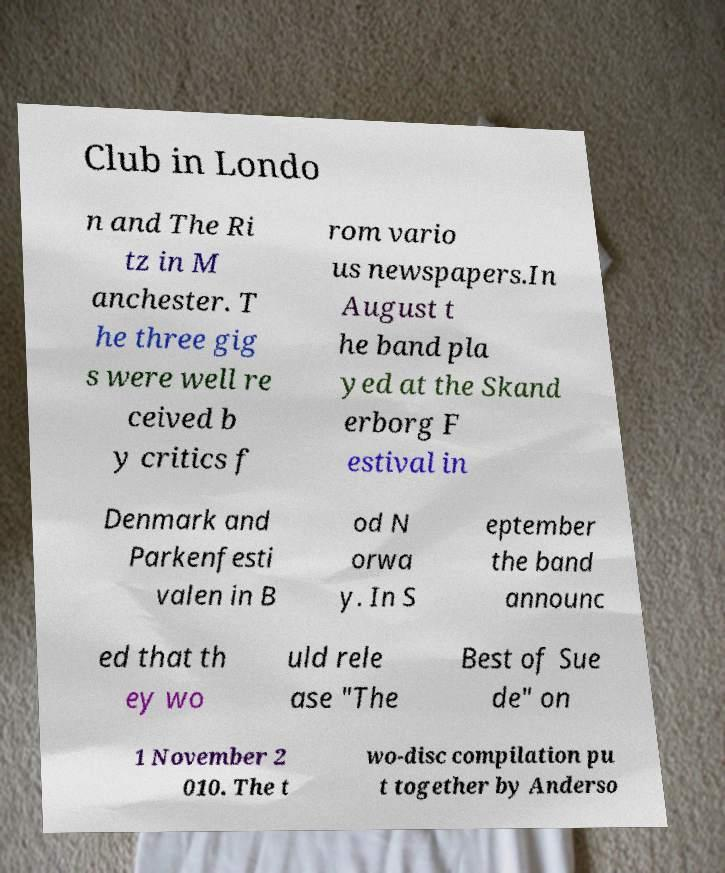There's text embedded in this image that I need extracted. Can you transcribe it verbatim? Club in Londo n and The Ri tz in M anchester. T he three gig s were well re ceived b y critics f rom vario us newspapers.In August t he band pla yed at the Skand erborg F estival in Denmark and Parkenfesti valen in B od N orwa y. In S eptember the band announc ed that th ey wo uld rele ase "The Best of Sue de" on 1 November 2 010. The t wo-disc compilation pu t together by Anderso 